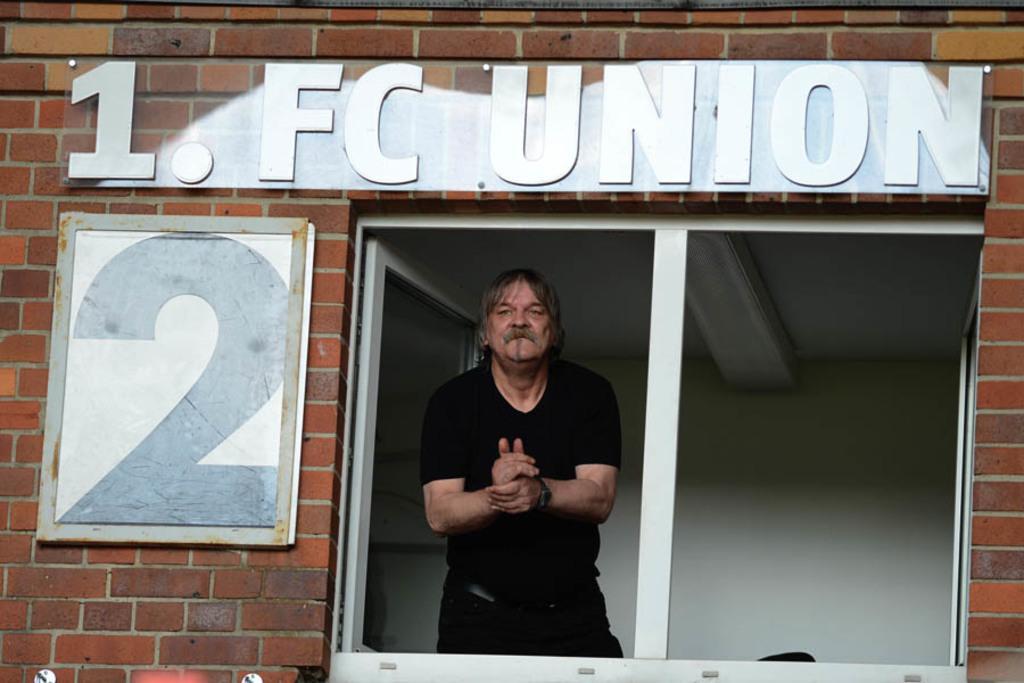Could you give a brief overview of what you see in this image? In the image there is a brick wall. On the wall there is a name board and also there is a board with two digit on it. Also there is a window to the wall. Inside the window there is a man with black t-shirt is standing. 